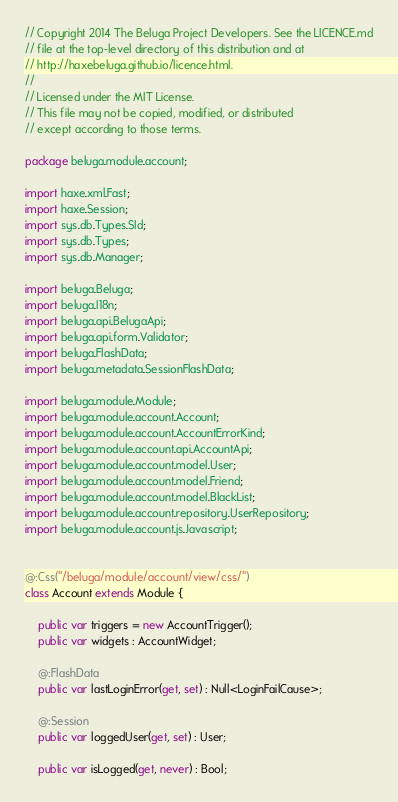<code> <loc_0><loc_0><loc_500><loc_500><_Haxe_>// Copyright 2014 The Beluga Project Developers. See the LICENCE.md
// file at the top-level directory of this distribution and at
// http://haxebeluga.github.io/licence.html.
//
// Licensed under the MIT License.
// This file may not be copied, modified, or distributed
// except according to those terms.

package beluga.module.account;

import haxe.xml.Fast;
import haxe.Session;
import sys.db.Types.SId;
import sys.db.Types;
import sys.db.Manager;

import beluga.Beluga;
import beluga.I18n;
import beluga.api.BelugaApi;
import beluga.api.form.Validator;
import beluga.FlashData;
import beluga.metadata.SessionFlashData;

import beluga.module.Module;
import beluga.module.account.Account;
import beluga.module.account.AccountErrorKind;
import beluga.module.account.api.AccountApi;
import beluga.module.account.model.User;
import beluga.module.account.model.Friend;
import beluga.module.account.model.BlackList;
import beluga.module.account.repository.UserRepository;
import beluga.module.account.js.Javascript;


@:Css("/beluga/module/account/view/css/")
class Account extends Module {

    public var triggers = new AccountTrigger();
    public var widgets : AccountWidget;

    @:FlashData
    public var lastLoginError(get, set) : Null<LoginFailCause>;

    @:Session
    public var loggedUser(get, set) : User;

    public var isLogged(get, never) : Bool;
</code> 